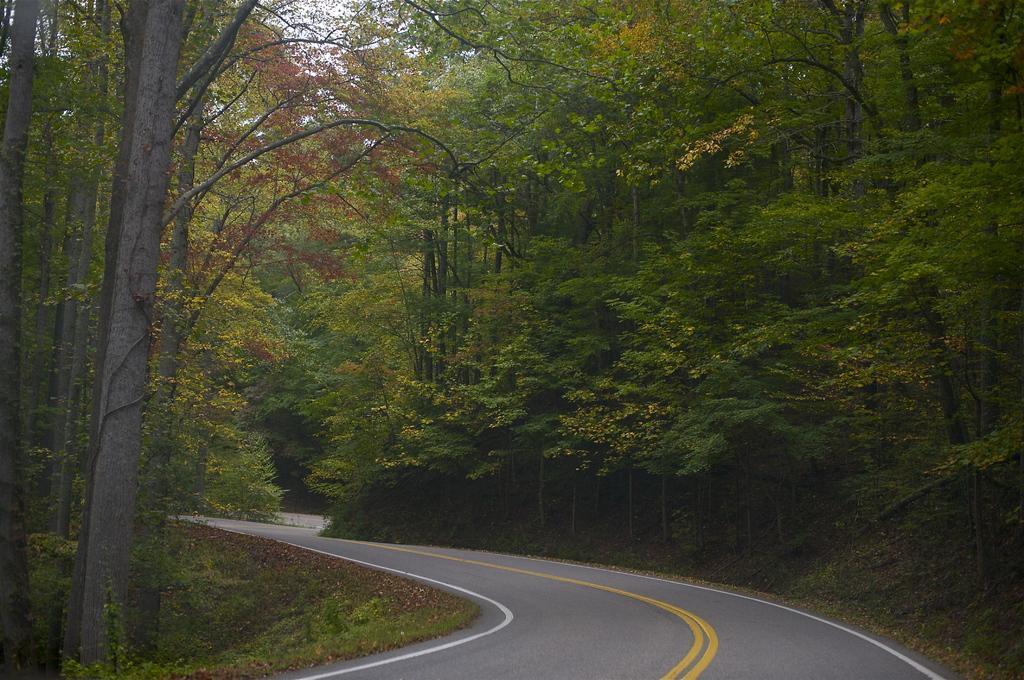In one or two sentences, can you explain what this image depicts? In front of the image there is a road, beside the road there are dry leaves, grass and plants. 